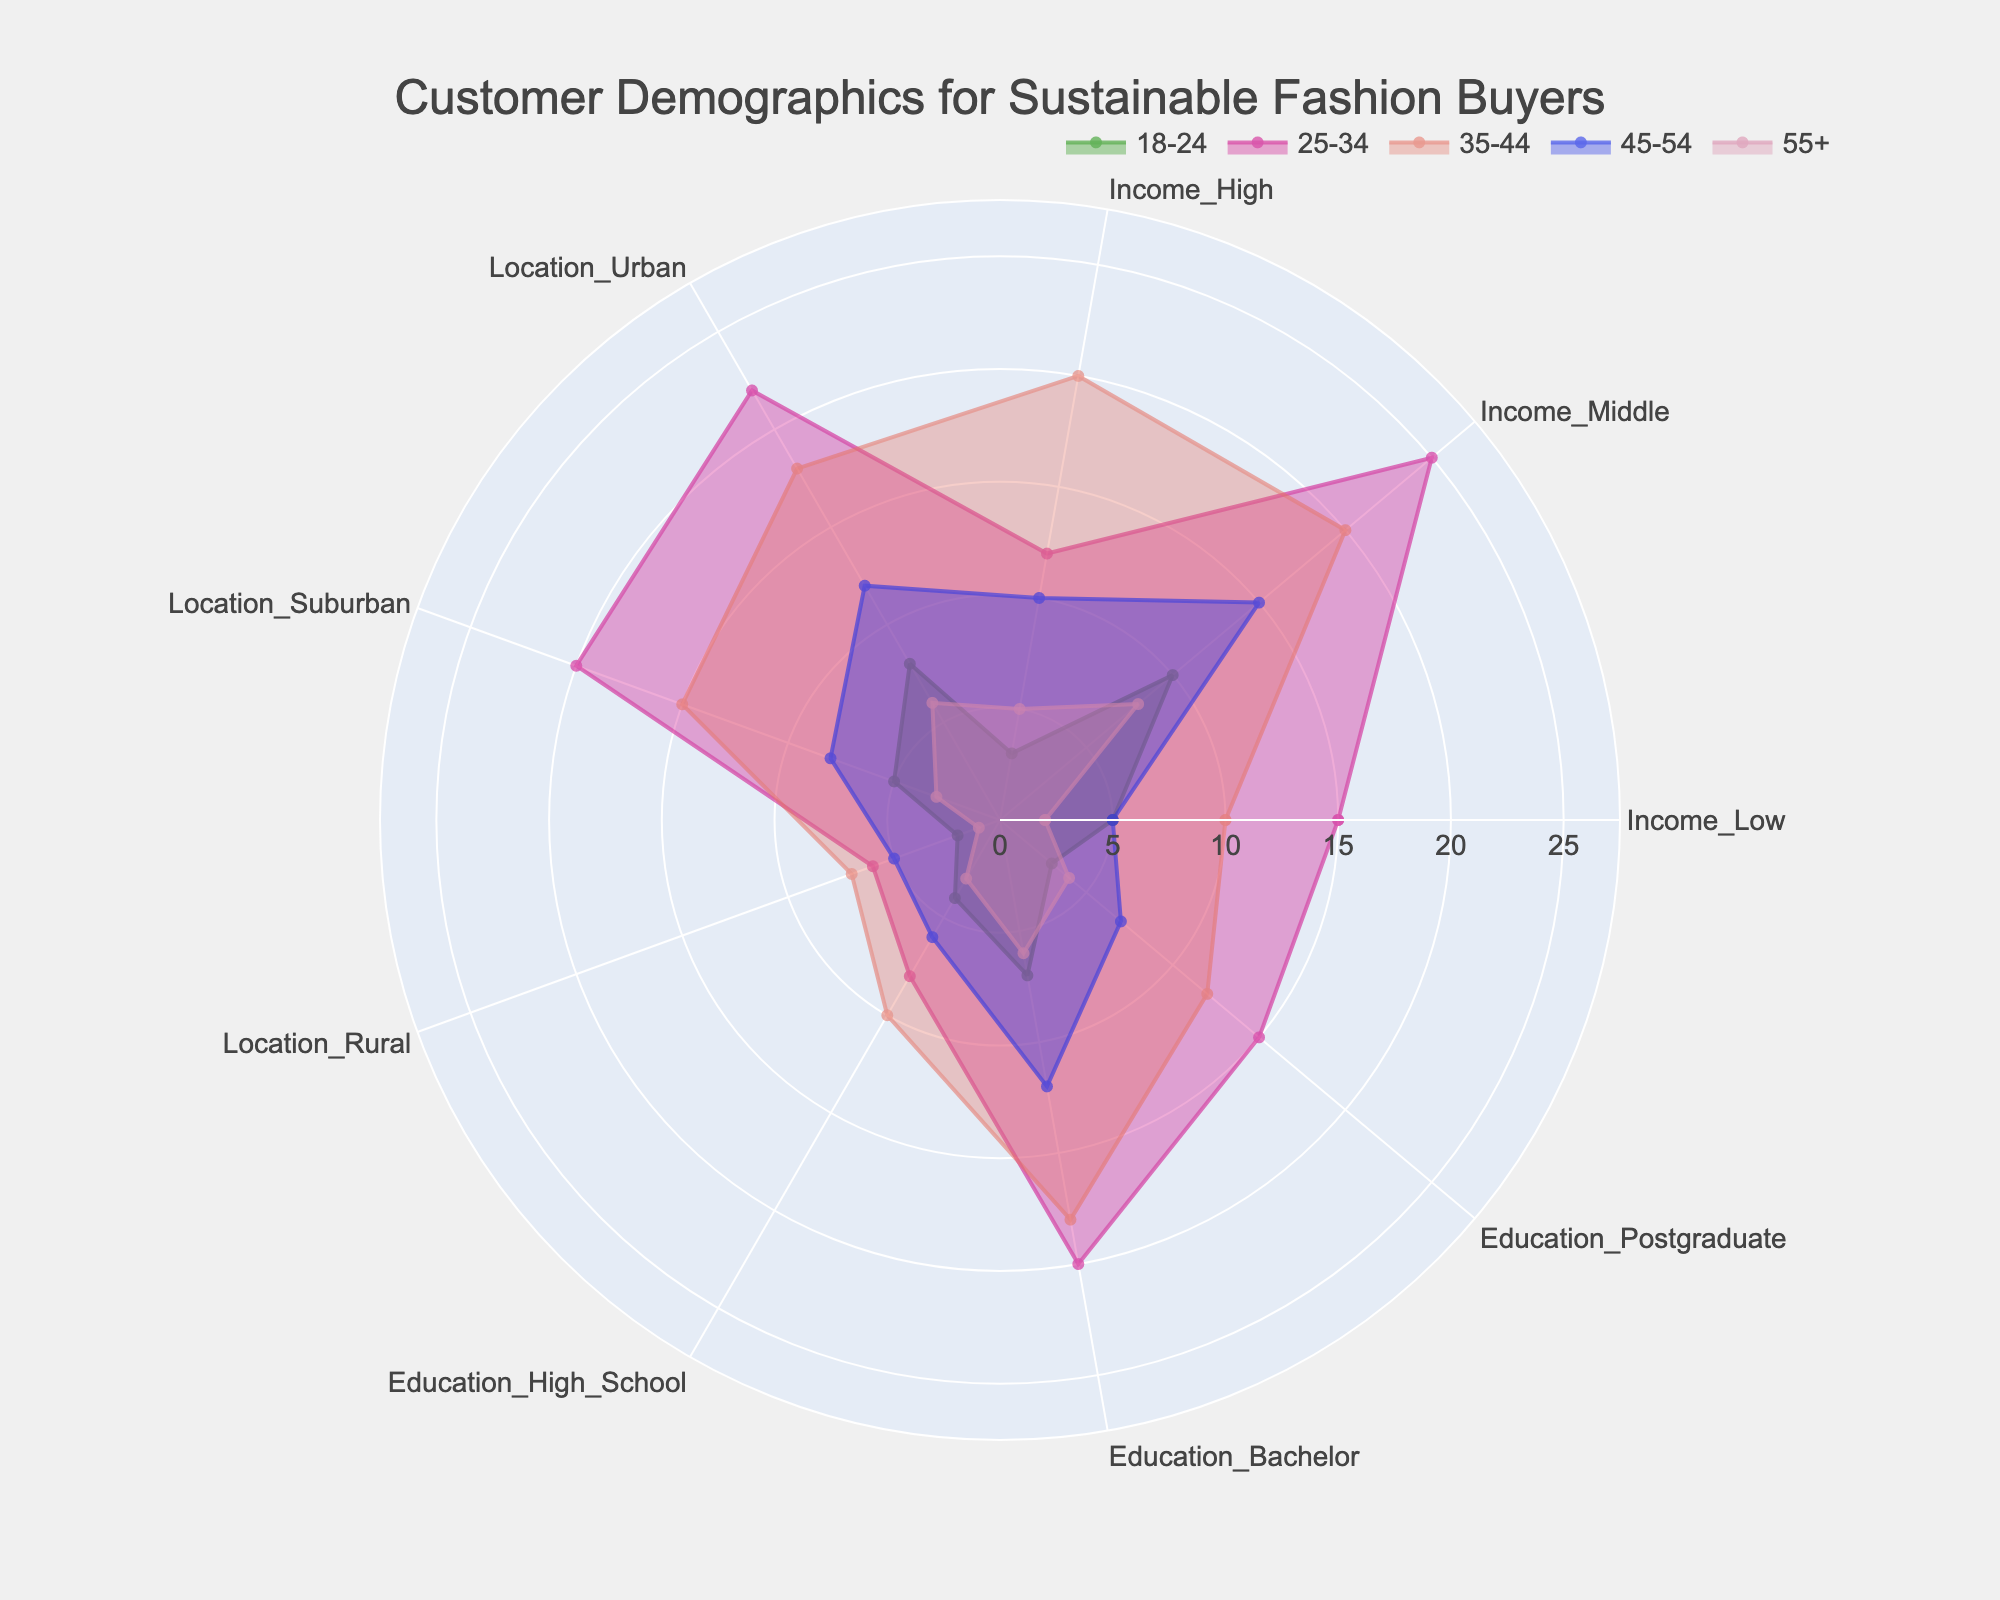What is the title of the figure? The title of the figure is located at the top and it provides a summary of what the figure is about.
Answer: Customer Demographics for Sustainable Fashion Buyers Which age group has the highest number of customers with a middle income? By comparing the values across the "Income_Middle" category for different age groups, the highest value is in the 25-34 age group, which is 25.
Answer: 25-34 What is the range of the radial axis? The range of the radial axis is from 0 to a value slightly higher than the highest count, which can be observed as 27.5 (25 * 1.1) based on the data provided.
Answer: 0 to 27.5 What are the two categories with the lowest count in the 55+ age group? Looking at the values for 55+ age group across all categories, the lowest counts are in "Location_Rural" and "Income_Low" with values of 1 and 2 respectively.
Answer: Location_Rural and Income_Low Which education level has the most buyers in the 35-44 age group? Comparing the values in the 35-44 age group for each education level, the highest is "Education_Bachelor" with a value of 18.
Answer: Education_Bachelor What is the sum of customers from suburban locations across all age groups? Adding the values for "Location_Suburban" across all age groups: 5 + 20 + 15 + 8 + 3 = 51
Answer: 51 How does the number of urban location buyers in the 25-34 age group compare to the 45-54 age group? The count of buyers in urban locations for 25-34 is 22 and for 45-54 is 12. Thus, the 25-34 age group has 10 more buyers than the 45-54 age group.
Answer: 10 more in 25-34 Which category shows the most variation across different age groups? Variability can be judged by the spread of values in a category across all age groups. "Income_Middle" has the most variation, ranging from 8 to 25.
Answer: Income_Middle Which age group has the least number of high income buyers and how many are there? By inspecting the "Income_High" category across all age groups, the 18-24 age group has the least with only 3 buyers.
Answer: 18-24 with 3 Is the number of postgraduate-educated buyers in the 45-54 age group greater than those in the 55+ age group? Comparing the counts for "Education_Postgraduate" in the 45-54 (7) and 55+ (4) age groups, it is clear that the former has more buyers.
Answer: Yes, 7 compared to 4 